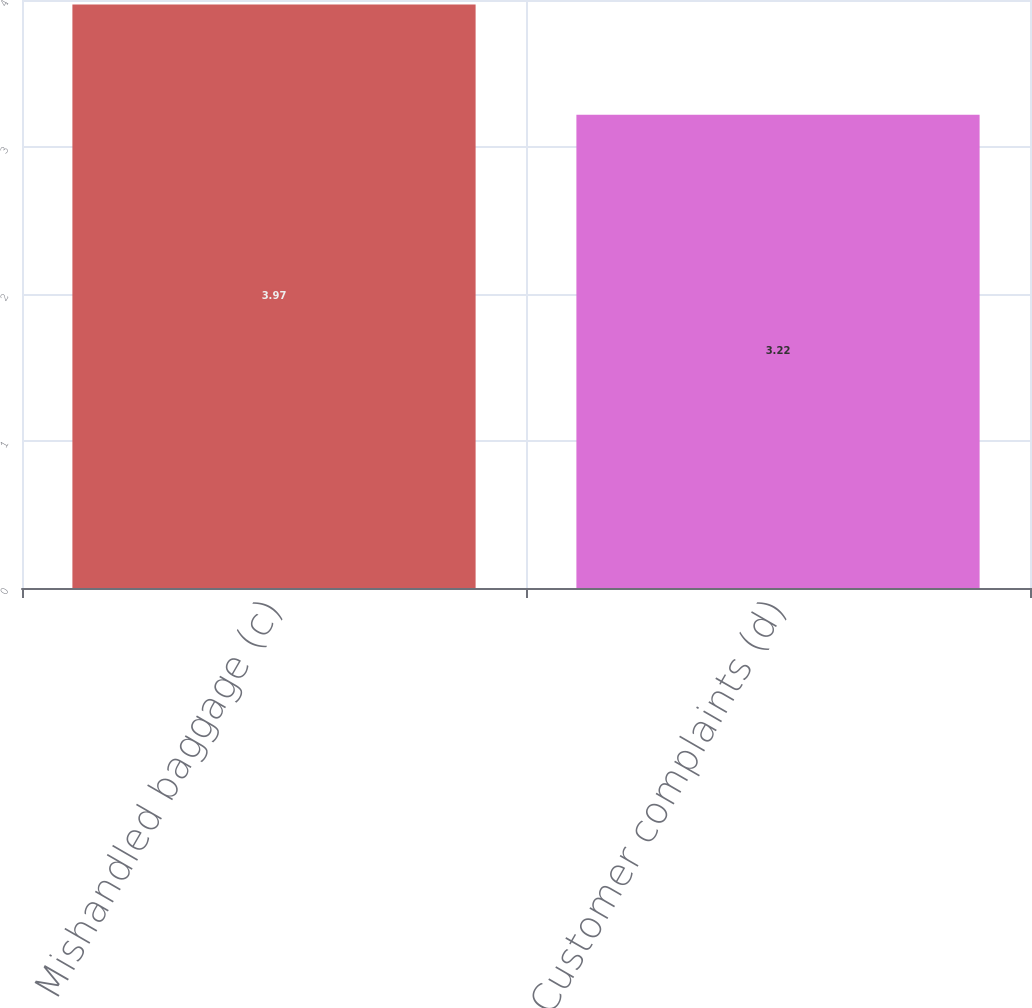Convert chart. <chart><loc_0><loc_0><loc_500><loc_500><bar_chart><fcel>Mishandled baggage (c)<fcel>Customer complaints (d)<nl><fcel>3.97<fcel>3.22<nl></chart> 